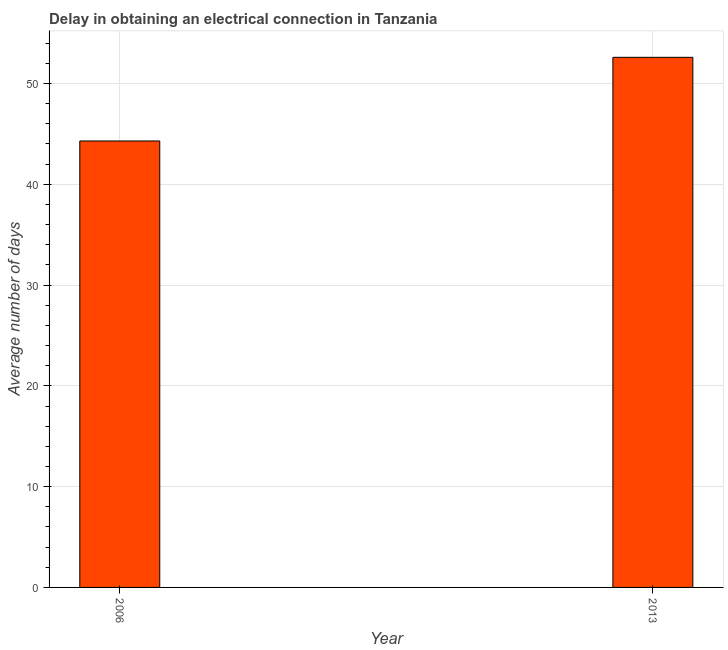Does the graph contain any zero values?
Keep it short and to the point. No. Does the graph contain grids?
Provide a succinct answer. Yes. What is the title of the graph?
Give a very brief answer. Delay in obtaining an electrical connection in Tanzania. What is the label or title of the X-axis?
Make the answer very short. Year. What is the label or title of the Y-axis?
Your answer should be very brief. Average number of days. What is the dalay in electrical connection in 2013?
Your response must be concise. 52.6. Across all years, what is the maximum dalay in electrical connection?
Your response must be concise. 52.6. Across all years, what is the minimum dalay in electrical connection?
Your answer should be very brief. 44.3. What is the sum of the dalay in electrical connection?
Provide a short and direct response. 96.9. What is the average dalay in electrical connection per year?
Your response must be concise. 48.45. What is the median dalay in electrical connection?
Your answer should be very brief. 48.45. Do a majority of the years between 2006 and 2013 (inclusive) have dalay in electrical connection greater than 34 days?
Provide a short and direct response. Yes. What is the ratio of the dalay in electrical connection in 2006 to that in 2013?
Keep it short and to the point. 0.84. Is the dalay in electrical connection in 2006 less than that in 2013?
Make the answer very short. Yes. How many years are there in the graph?
Your response must be concise. 2. What is the difference between two consecutive major ticks on the Y-axis?
Offer a terse response. 10. Are the values on the major ticks of Y-axis written in scientific E-notation?
Your answer should be very brief. No. What is the Average number of days in 2006?
Ensure brevity in your answer.  44.3. What is the Average number of days of 2013?
Provide a short and direct response. 52.6. What is the ratio of the Average number of days in 2006 to that in 2013?
Provide a short and direct response. 0.84. 